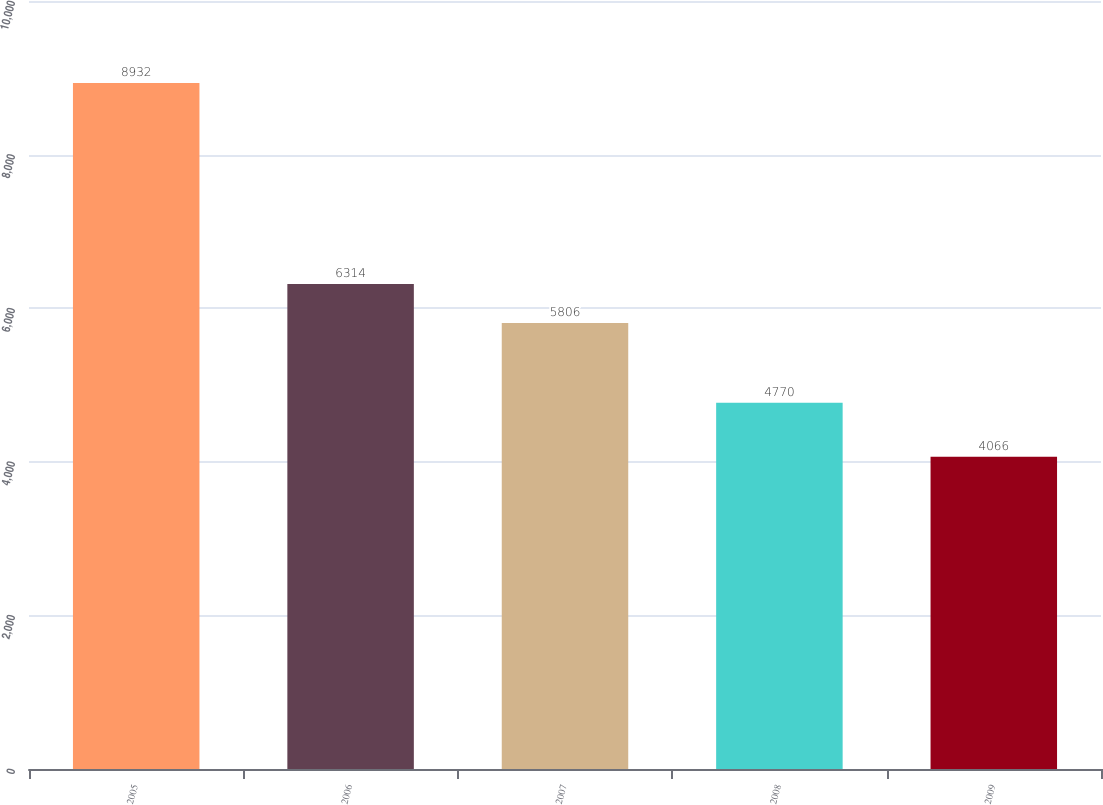<chart> <loc_0><loc_0><loc_500><loc_500><bar_chart><fcel>2005<fcel>2006<fcel>2007<fcel>2008<fcel>2009<nl><fcel>8932<fcel>6314<fcel>5806<fcel>4770<fcel>4066<nl></chart> 